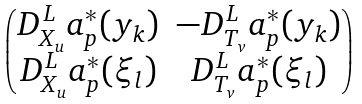<formula> <loc_0><loc_0><loc_500><loc_500>\begin{pmatrix} D ^ { L } _ { X _ { u } } a _ { p } ^ { * } ( y _ { k } ) & - D ^ { L } _ { T _ { v } } a _ { p } ^ { * } ( y _ { k } ) \\ D ^ { L } _ { X _ { u } } a _ { p } ^ { * } ( \xi _ { l } ) & D ^ { L } _ { T _ { v } } a _ { p } ^ { * } ( \xi _ { l } ) \end{pmatrix}</formula> 